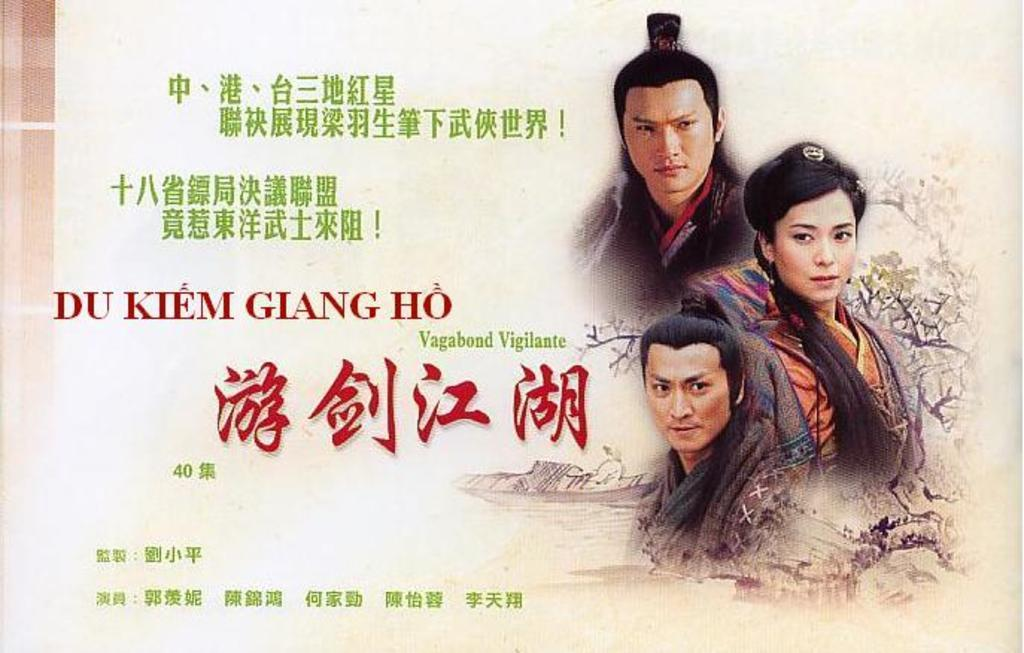What type of visual representation is shown in the image? The image is a poster. Who or what can be seen on the poster? There are people depicted on the poster. What additional details can be found on the poster? There is some information present on the poster. What type of rifle is being used by the mother in the image? There is no mother or rifle present in the image; it only depicts people and information on a poster. 